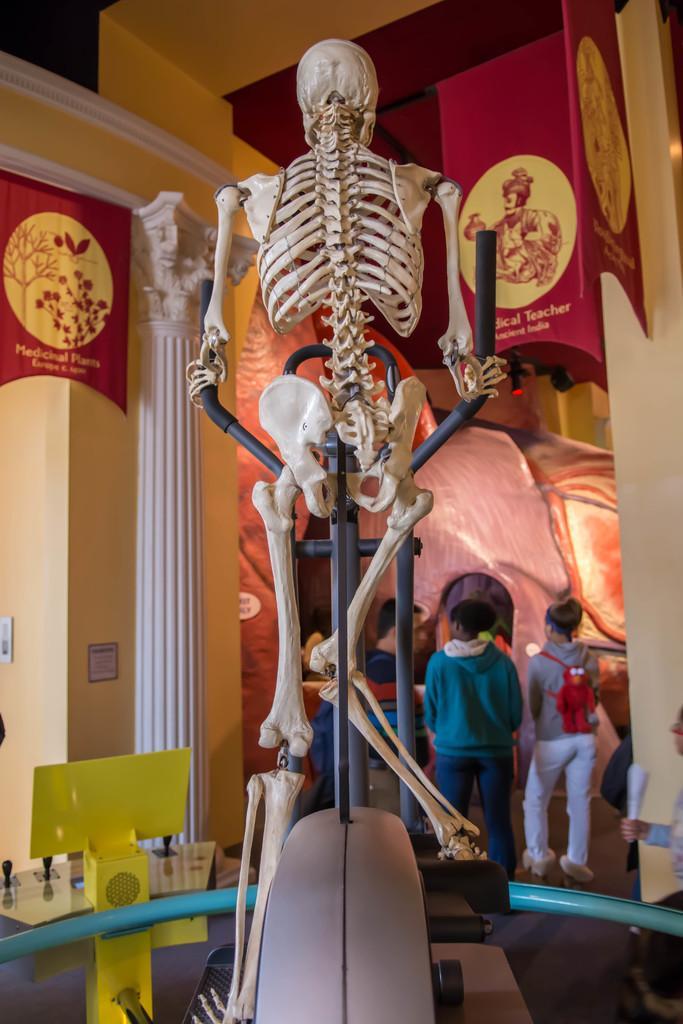How would you summarize this image in a sentence or two? In this image we can see a skeleton placed on the stand. In the background we can see walls, advertisement boards and persons standing on the floor. 